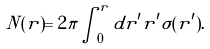Convert formula to latex. <formula><loc_0><loc_0><loc_500><loc_500>N ( r ) = 2 \pi \int _ { 0 } ^ { r } d r ^ { \prime } r ^ { \prime } \sigma ( r ^ { \prime } ) .</formula> 